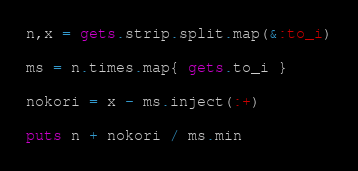Convert code to text. <code><loc_0><loc_0><loc_500><loc_500><_Ruby_>n,x = gets.strip.split.map(&:to_i)

ms = n.times.map{ gets.to_i }

nokori = x - ms.inject(:+)

puts n + nokori / ms.min
</code> 